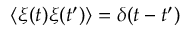<formula> <loc_0><loc_0><loc_500><loc_500>\langle \xi ( t ) \xi ( t ^ { \prime } ) \rangle = \delta ( t - t ^ { \prime } )</formula> 